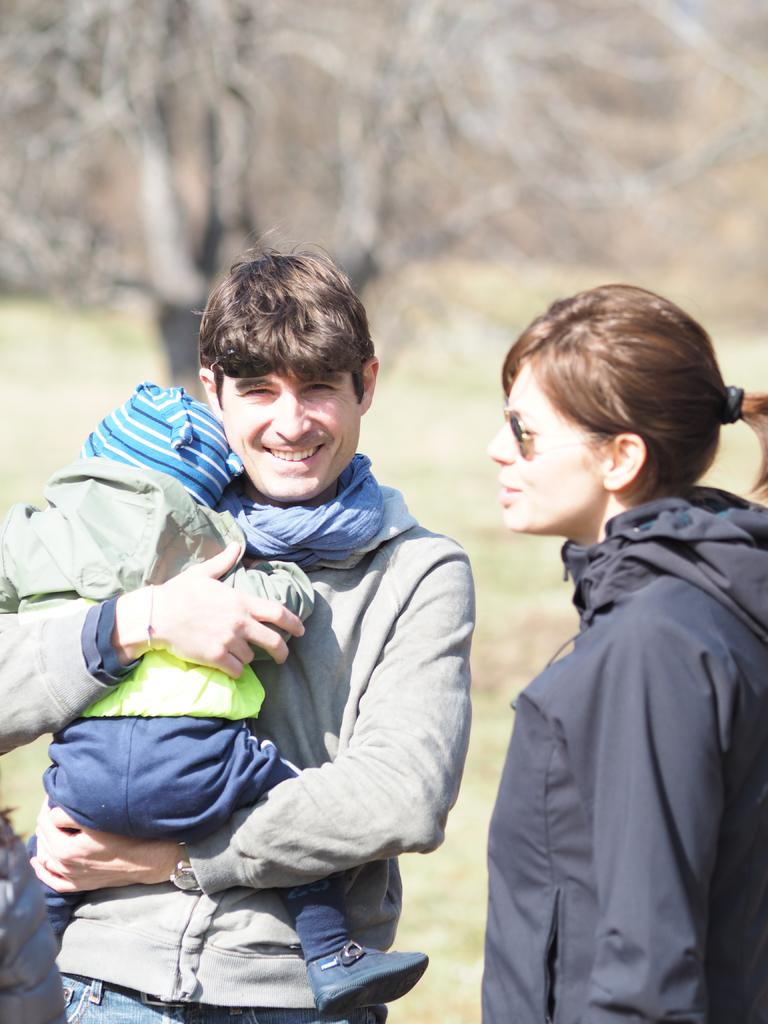How many people are present in the image? There are three people in the image. What can be observed about the clothing of the people in the image? The people are wearing different color dresses. What is visible in the background of the image? There is a tree in the background of the image. How would you describe the background of the image? The background of the image is blurred. What type of kettle can be seen in the hands of the people in the image? There is no kettle present in the image; the people are wearing different color dresses. Are there any giants visible in the image? There are no giants present in the image; it features three people wearing different color dresses. 